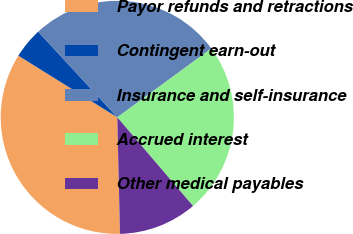Convert chart to OTSL. <chart><loc_0><loc_0><loc_500><loc_500><pie_chart><fcel>Payor refunds and retractions<fcel>Contingent earn-out<fcel>Insurance and self-insurance<fcel>Accrued interest<fcel>Other medical payables<nl><fcel>34.24%<fcel>4.26%<fcel>26.81%<fcel>23.81%<fcel>10.88%<nl></chart> 